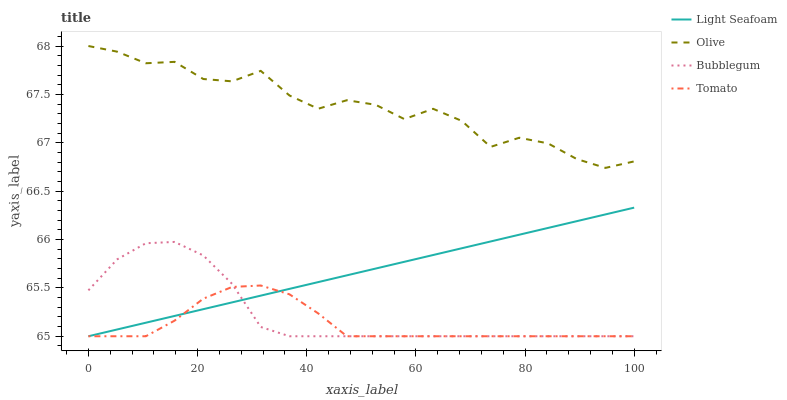Does Tomato have the minimum area under the curve?
Answer yes or no. Yes. Does Olive have the maximum area under the curve?
Answer yes or no. Yes. Does Light Seafoam have the minimum area under the curve?
Answer yes or no. No. Does Light Seafoam have the maximum area under the curve?
Answer yes or no. No. Is Light Seafoam the smoothest?
Answer yes or no. Yes. Is Olive the roughest?
Answer yes or no. Yes. Is Tomato the smoothest?
Answer yes or no. No. Is Tomato the roughest?
Answer yes or no. No. Does Olive have the highest value?
Answer yes or no. Yes. Does Light Seafoam have the highest value?
Answer yes or no. No. Is Bubblegum less than Olive?
Answer yes or no. Yes. Is Olive greater than Tomato?
Answer yes or no. Yes. Does Bubblegum intersect Olive?
Answer yes or no. No. 